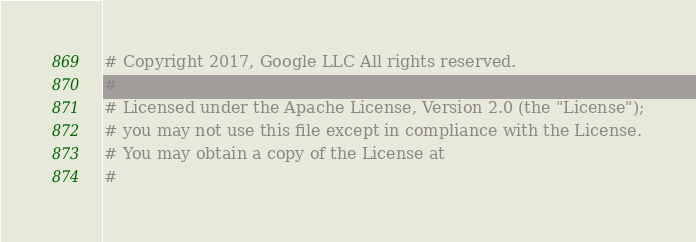Convert code to text. <code><loc_0><loc_0><loc_500><loc_500><_Python_># Copyright 2017, Google LLC All rights reserved.
#
# Licensed under the Apache License, Version 2.0 (the "License");
# you may not use this file except in compliance with the License.
# You may obtain a copy of the License at
#</code> 